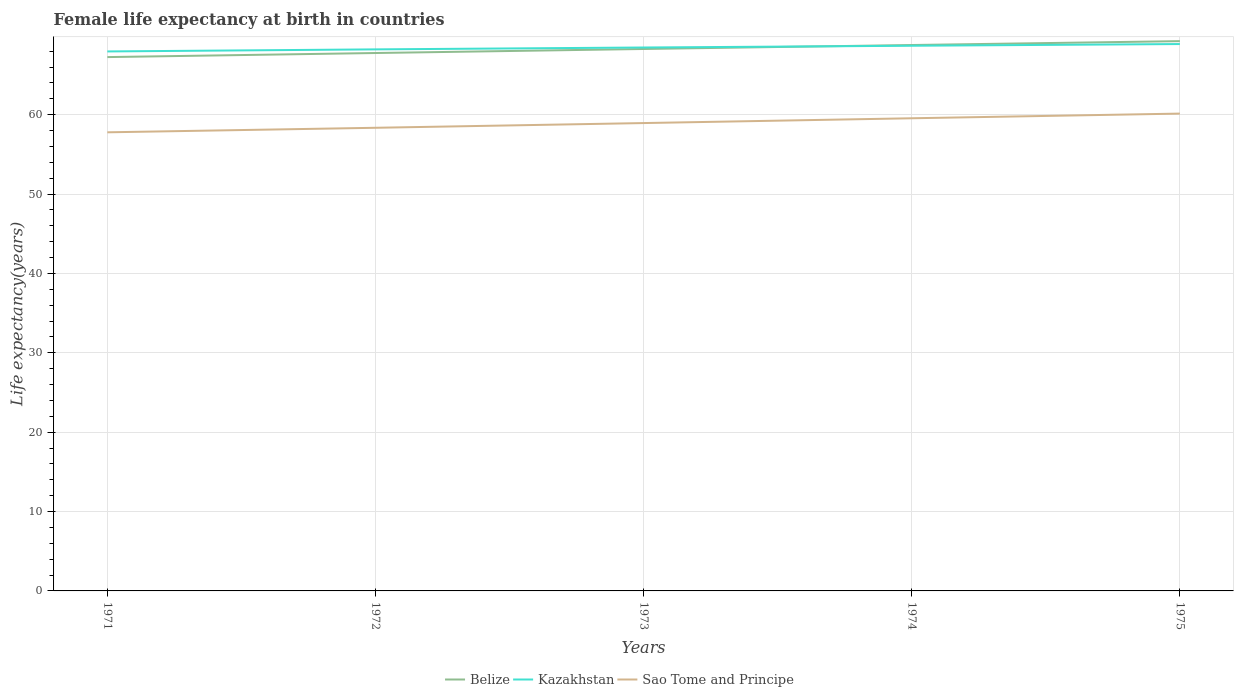Does the line corresponding to Belize intersect with the line corresponding to Sao Tome and Principe?
Your response must be concise. No. Is the number of lines equal to the number of legend labels?
Keep it short and to the point. Yes. Across all years, what is the maximum female life expectancy at birth in Belize?
Ensure brevity in your answer.  67.25. What is the total female life expectancy at birth in Kazakhstan in the graph?
Keep it short and to the point. -0.21. What is the difference between the highest and the second highest female life expectancy at birth in Sao Tome and Principe?
Offer a terse response. 2.36. Is the female life expectancy at birth in Kazakhstan strictly greater than the female life expectancy at birth in Sao Tome and Principe over the years?
Ensure brevity in your answer.  No. What is the difference between two consecutive major ticks on the Y-axis?
Offer a very short reply. 10. Are the values on the major ticks of Y-axis written in scientific E-notation?
Provide a short and direct response. No. Does the graph contain any zero values?
Offer a very short reply. No. Where does the legend appear in the graph?
Offer a terse response. Bottom center. What is the title of the graph?
Offer a very short reply. Female life expectancy at birth in countries. Does "St. Martin (French part)" appear as one of the legend labels in the graph?
Provide a short and direct response. No. What is the label or title of the Y-axis?
Make the answer very short. Life expectancy(years). What is the Life expectancy(years) in Belize in 1971?
Your answer should be compact. 67.25. What is the Life expectancy(years) in Kazakhstan in 1971?
Ensure brevity in your answer.  67.96. What is the Life expectancy(years) of Sao Tome and Principe in 1971?
Offer a terse response. 57.78. What is the Life expectancy(years) of Belize in 1972?
Offer a very short reply. 67.77. What is the Life expectancy(years) of Kazakhstan in 1972?
Make the answer very short. 68.22. What is the Life expectancy(years) in Sao Tome and Principe in 1972?
Offer a terse response. 58.35. What is the Life expectancy(years) in Belize in 1973?
Your answer should be very brief. 68.27. What is the Life expectancy(years) of Kazakhstan in 1973?
Your answer should be very brief. 68.46. What is the Life expectancy(years) of Sao Tome and Principe in 1973?
Provide a succinct answer. 58.94. What is the Life expectancy(years) in Belize in 1974?
Ensure brevity in your answer.  68.77. What is the Life expectancy(years) of Kazakhstan in 1974?
Your response must be concise. 68.68. What is the Life expectancy(years) in Sao Tome and Principe in 1974?
Offer a terse response. 59.55. What is the Life expectancy(years) of Belize in 1975?
Provide a succinct answer. 69.26. What is the Life expectancy(years) of Kazakhstan in 1975?
Your answer should be compact. 68.89. What is the Life expectancy(years) of Sao Tome and Principe in 1975?
Make the answer very short. 60.13. Across all years, what is the maximum Life expectancy(years) in Belize?
Your response must be concise. 69.26. Across all years, what is the maximum Life expectancy(years) in Kazakhstan?
Give a very brief answer. 68.89. Across all years, what is the maximum Life expectancy(years) in Sao Tome and Principe?
Your response must be concise. 60.13. Across all years, what is the minimum Life expectancy(years) of Belize?
Provide a succinct answer. 67.25. Across all years, what is the minimum Life expectancy(years) in Kazakhstan?
Offer a terse response. 67.96. Across all years, what is the minimum Life expectancy(years) of Sao Tome and Principe?
Provide a short and direct response. 57.78. What is the total Life expectancy(years) of Belize in the graph?
Make the answer very short. 341.33. What is the total Life expectancy(years) in Kazakhstan in the graph?
Provide a short and direct response. 342.22. What is the total Life expectancy(years) in Sao Tome and Principe in the graph?
Offer a terse response. 294.74. What is the difference between the Life expectancy(years) of Belize in 1971 and that in 1972?
Provide a succinct answer. -0.51. What is the difference between the Life expectancy(years) in Kazakhstan in 1971 and that in 1972?
Offer a terse response. -0.26. What is the difference between the Life expectancy(years) of Sao Tome and Principe in 1971 and that in 1972?
Give a very brief answer. -0.57. What is the difference between the Life expectancy(years) in Belize in 1971 and that in 1973?
Ensure brevity in your answer.  -1.02. What is the difference between the Life expectancy(years) in Kazakhstan in 1971 and that in 1973?
Your response must be concise. -0.5. What is the difference between the Life expectancy(years) of Sao Tome and Principe in 1971 and that in 1973?
Provide a short and direct response. -1.17. What is the difference between the Life expectancy(years) of Belize in 1971 and that in 1974?
Make the answer very short. -1.52. What is the difference between the Life expectancy(years) of Kazakhstan in 1971 and that in 1974?
Provide a short and direct response. -0.72. What is the difference between the Life expectancy(years) of Sao Tome and Principe in 1971 and that in 1974?
Offer a very short reply. -1.77. What is the difference between the Life expectancy(years) in Belize in 1971 and that in 1975?
Your answer should be compact. -2.01. What is the difference between the Life expectancy(years) in Kazakhstan in 1971 and that in 1975?
Your response must be concise. -0.93. What is the difference between the Life expectancy(years) in Sao Tome and Principe in 1971 and that in 1975?
Offer a very short reply. -2.36. What is the difference between the Life expectancy(years) of Belize in 1972 and that in 1973?
Keep it short and to the point. -0.51. What is the difference between the Life expectancy(years) of Kazakhstan in 1972 and that in 1973?
Make the answer very short. -0.24. What is the difference between the Life expectancy(years) in Sao Tome and Principe in 1972 and that in 1973?
Make the answer very short. -0.59. What is the difference between the Life expectancy(years) of Belize in 1972 and that in 1974?
Provide a short and direct response. -1.01. What is the difference between the Life expectancy(years) in Kazakhstan in 1972 and that in 1974?
Your answer should be compact. -0.46. What is the difference between the Life expectancy(years) of Sao Tome and Principe in 1972 and that in 1974?
Provide a succinct answer. -1.2. What is the difference between the Life expectancy(years) of Belize in 1972 and that in 1975?
Offer a terse response. -1.5. What is the difference between the Life expectancy(years) of Kazakhstan in 1972 and that in 1975?
Your response must be concise. -0.67. What is the difference between the Life expectancy(years) in Sao Tome and Principe in 1972 and that in 1975?
Your answer should be compact. -1.79. What is the difference between the Life expectancy(years) of Kazakhstan in 1973 and that in 1974?
Provide a short and direct response. -0.22. What is the difference between the Life expectancy(years) of Sao Tome and Principe in 1973 and that in 1974?
Your answer should be very brief. -0.6. What is the difference between the Life expectancy(years) of Belize in 1973 and that in 1975?
Provide a succinct answer. -0.99. What is the difference between the Life expectancy(years) of Kazakhstan in 1973 and that in 1975?
Give a very brief answer. -0.43. What is the difference between the Life expectancy(years) of Sao Tome and Principe in 1973 and that in 1975?
Your answer should be very brief. -1.19. What is the difference between the Life expectancy(years) in Belize in 1974 and that in 1975?
Make the answer very short. -0.49. What is the difference between the Life expectancy(years) of Kazakhstan in 1974 and that in 1975?
Offer a very short reply. -0.21. What is the difference between the Life expectancy(years) of Sao Tome and Principe in 1974 and that in 1975?
Your response must be concise. -0.59. What is the difference between the Life expectancy(years) in Belize in 1971 and the Life expectancy(years) in Kazakhstan in 1972?
Give a very brief answer. -0.97. What is the difference between the Life expectancy(years) in Belize in 1971 and the Life expectancy(years) in Sao Tome and Principe in 1972?
Keep it short and to the point. 8.9. What is the difference between the Life expectancy(years) in Kazakhstan in 1971 and the Life expectancy(years) in Sao Tome and Principe in 1972?
Give a very brief answer. 9.62. What is the difference between the Life expectancy(years) in Belize in 1971 and the Life expectancy(years) in Kazakhstan in 1973?
Make the answer very short. -1.21. What is the difference between the Life expectancy(years) of Belize in 1971 and the Life expectancy(years) of Sao Tome and Principe in 1973?
Your answer should be very brief. 8.31. What is the difference between the Life expectancy(years) in Kazakhstan in 1971 and the Life expectancy(years) in Sao Tome and Principe in 1973?
Provide a short and direct response. 9.02. What is the difference between the Life expectancy(years) in Belize in 1971 and the Life expectancy(years) in Kazakhstan in 1974?
Give a very brief answer. -1.43. What is the difference between the Life expectancy(years) of Belize in 1971 and the Life expectancy(years) of Sao Tome and Principe in 1974?
Offer a terse response. 7.71. What is the difference between the Life expectancy(years) of Kazakhstan in 1971 and the Life expectancy(years) of Sao Tome and Principe in 1974?
Provide a short and direct response. 8.42. What is the difference between the Life expectancy(years) of Belize in 1971 and the Life expectancy(years) of Kazakhstan in 1975?
Your answer should be compact. -1.64. What is the difference between the Life expectancy(years) of Belize in 1971 and the Life expectancy(years) of Sao Tome and Principe in 1975?
Provide a short and direct response. 7.12. What is the difference between the Life expectancy(years) of Kazakhstan in 1971 and the Life expectancy(years) of Sao Tome and Principe in 1975?
Ensure brevity in your answer.  7.83. What is the difference between the Life expectancy(years) of Belize in 1972 and the Life expectancy(years) of Kazakhstan in 1973?
Provide a short and direct response. -0.69. What is the difference between the Life expectancy(years) in Belize in 1972 and the Life expectancy(years) in Sao Tome and Principe in 1973?
Your answer should be compact. 8.82. What is the difference between the Life expectancy(years) of Kazakhstan in 1972 and the Life expectancy(years) of Sao Tome and Principe in 1973?
Offer a very short reply. 9.28. What is the difference between the Life expectancy(years) in Belize in 1972 and the Life expectancy(years) in Kazakhstan in 1974?
Provide a succinct answer. -0.91. What is the difference between the Life expectancy(years) in Belize in 1972 and the Life expectancy(years) in Sao Tome and Principe in 1974?
Your answer should be compact. 8.22. What is the difference between the Life expectancy(years) in Kazakhstan in 1972 and the Life expectancy(years) in Sao Tome and Principe in 1974?
Offer a terse response. 8.68. What is the difference between the Life expectancy(years) in Belize in 1972 and the Life expectancy(years) in Kazakhstan in 1975?
Your answer should be very brief. -1.13. What is the difference between the Life expectancy(years) in Belize in 1972 and the Life expectancy(years) in Sao Tome and Principe in 1975?
Give a very brief answer. 7.63. What is the difference between the Life expectancy(years) of Kazakhstan in 1972 and the Life expectancy(years) of Sao Tome and Principe in 1975?
Give a very brief answer. 8.09. What is the difference between the Life expectancy(years) in Belize in 1973 and the Life expectancy(years) in Kazakhstan in 1974?
Offer a very short reply. -0.41. What is the difference between the Life expectancy(years) of Belize in 1973 and the Life expectancy(years) of Sao Tome and Principe in 1974?
Your answer should be compact. 8.73. What is the difference between the Life expectancy(years) of Kazakhstan in 1973 and the Life expectancy(years) of Sao Tome and Principe in 1974?
Your answer should be very brief. 8.91. What is the difference between the Life expectancy(years) of Belize in 1973 and the Life expectancy(years) of Kazakhstan in 1975?
Your response must be concise. -0.62. What is the difference between the Life expectancy(years) in Belize in 1973 and the Life expectancy(years) in Sao Tome and Principe in 1975?
Provide a succinct answer. 8.14. What is the difference between the Life expectancy(years) in Kazakhstan in 1973 and the Life expectancy(years) in Sao Tome and Principe in 1975?
Offer a very short reply. 8.33. What is the difference between the Life expectancy(years) of Belize in 1974 and the Life expectancy(years) of Kazakhstan in 1975?
Keep it short and to the point. -0.12. What is the difference between the Life expectancy(years) in Belize in 1974 and the Life expectancy(years) in Sao Tome and Principe in 1975?
Your response must be concise. 8.64. What is the difference between the Life expectancy(years) of Kazakhstan in 1974 and the Life expectancy(years) of Sao Tome and Principe in 1975?
Ensure brevity in your answer.  8.55. What is the average Life expectancy(years) in Belize per year?
Ensure brevity in your answer.  68.27. What is the average Life expectancy(years) in Kazakhstan per year?
Your response must be concise. 68.44. What is the average Life expectancy(years) in Sao Tome and Principe per year?
Your response must be concise. 58.95. In the year 1971, what is the difference between the Life expectancy(years) in Belize and Life expectancy(years) in Kazakhstan?
Provide a short and direct response. -0.71. In the year 1971, what is the difference between the Life expectancy(years) of Belize and Life expectancy(years) of Sao Tome and Principe?
Provide a short and direct response. 9.48. In the year 1971, what is the difference between the Life expectancy(years) of Kazakhstan and Life expectancy(years) of Sao Tome and Principe?
Your response must be concise. 10.19. In the year 1972, what is the difference between the Life expectancy(years) in Belize and Life expectancy(years) in Kazakhstan?
Your answer should be very brief. -0.46. In the year 1972, what is the difference between the Life expectancy(years) in Belize and Life expectancy(years) in Sao Tome and Principe?
Provide a succinct answer. 9.42. In the year 1972, what is the difference between the Life expectancy(years) of Kazakhstan and Life expectancy(years) of Sao Tome and Principe?
Provide a short and direct response. 9.88. In the year 1973, what is the difference between the Life expectancy(years) of Belize and Life expectancy(years) of Kazakhstan?
Offer a terse response. -0.19. In the year 1973, what is the difference between the Life expectancy(years) of Belize and Life expectancy(years) of Sao Tome and Principe?
Your answer should be compact. 9.33. In the year 1973, what is the difference between the Life expectancy(years) in Kazakhstan and Life expectancy(years) in Sao Tome and Principe?
Provide a short and direct response. 9.52. In the year 1974, what is the difference between the Life expectancy(years) in Belize and Life expectancy(years) in Kazakhstan?
Your answer should be compact. 0.09. In the year 1974, what is the difference between the Life expectancy(years) of Belize and Life expectancy(years) of Sao Tome and Principe?
Your answer should be compact. 9.23. In the year 1974, what is the difference between the Life expectancy(years) in Kazakhstan and Life expectancy(years) in Sao Tome and Principe?
Your answer should be very brief. 9.13. In the year 1975, what is the difference between the Life expectancy(years) in Belize and Life expectancy(years) in Kazakhstan?
Make the answer very short. 0.37. In the year 1975, what is the difference between the Life expectancy(years) of Belize and Life expectancy(years) of Sao Tome and Principe?
Offer a terse response. 9.13. In the year 1975, what is the difference between the Life expectancy(years) of Kazakhstan and Life expectancy(years) of Sao Tome and Principe?
Your answer should be very brief. 8.76. What is the ratio of the Life expectancy(years) of Belize in 1971 to that in 1972?
Provide a succinct answer. 0.99. What is the ratio of the Life expectancy(years) in Kazakhstan in 1971 to that in 1972?
Offer a very short reply. 1. What is the ratio of the Life expectancy(years) of Sao Tome and Principe in 1971 to that in 1972?
Provide a short and direct response. 0.99. What is the ratio of the Life expectancy(years) of Belize in 1971 to that in 1973?
Your answer should be very brief. 0.98. What is the ratio of the Life expectancy(years) in Sao Tome and Principe in 1971 to that in 1973?
Ensure brevity in your answer.  0.98. What is the ratio of the Life expectancy(years) in Belize in 1971 to that in 1974?
Your answer should be compact. 0.98. What is the ratio of the Life expectancy(years) of Sao Tome and Principe in 1971 to that in 1974?
Ensure brevity in your answer.  0.97. What is the ratio of the Life expectancy(years) of Kazakhstan in 1971 to that in 1975?
Your answer should be very brief. 0.99. What is the ratio of the Life expectancy(years) in Sao Tome and Principe in 1971 to that in 1975?
Offer a terse response. 0.96. What is the ratio of the Life expectancy(years) in Belize in 1972 to that in 1973?
Provide a short and direct response. 0.99. What is the ratio of the Life expectancy(years) in Sao Tome and Principe in 1972 to that in 1973?
Offer a terse response. 0.99. What is the ratio of the Life expectancy(years) of Belize in 1972 to that in 1974?
Offer a very short reply. 0.99. What is the ratio of the Life expectancy(years) of Kazakhstan in 1972 to that in 1974?
Your answer should be compact. 0.99. What is the ratio of the Life expectancy(years) in Sao Tome and Principe in 1972 to that in 1974?
Provide a short and direct response. 0.98. What is the ratio of the Life expectancy(years) of Belize in 1972 to that in 1975?
Provide a succinct answer. 0.98. What is the ratio of the Life expectancy(years) of Kazakhstan in 1972 to that in 1975?
Offer a terse response. 0.99. What is the ratio of the Life expectancy(years) of Sao Tome and Principe in 1972 to that in 1975?
Your answer should be compact. 0.97. What is the ratio of the Life expectancy(years) of Kazakhstan in 1973 to that in 1974?
Ensure brevity in your answer.  1. What is the ratio of the Life expectancy(years) of Belize in 1973 to that in 1975?
Ensure brevity in your answer.  0.99. What is the ratio of the Life expectancy(years) in Sao Tome and Principe in 1973 to that in 1975?
Give a very brief answer. 0.98. What is the ratio of the Life expectancy(years) in Belize in 1974 to that in 1975?
Your answer should be very brief. 0.99. What is the ratio of the Life expectancy(years) of Kazakhstan in 1974 to that in 1975?
Your response must be concise. 1. What is the ratio of the Life expectancy(years) in Sao Tome and Principe in 1974 to that in 1975?
Ensure brevity in your answer.  0.99. What is the difference between the highest and the second highest Life expectancy(years) of Belize?
Your answer should be compact. 0.49. What is the difference between the highest and the second highest Life expectancy(years) of Kazakhstan?
Your answer should be compact. 0.21. What is the difference between the highest and the second highest Life expectancy(years) in Sao Tome and Principe?
Provide a succinct answer. 0.59. What is the difference between the highest and the lowest Life expectancy(years) in Belize?
Provide a short and direct response. 2.01. What is the difference between the highest and the lowest Life expectancy(years) in Kazakhstan?
Ensure brevity in your answer.  0.93. What is the difference between the highest and the lowest Life expectancy(years) in Sao Tome and Principe?
Your response must be concise. 2.36. 